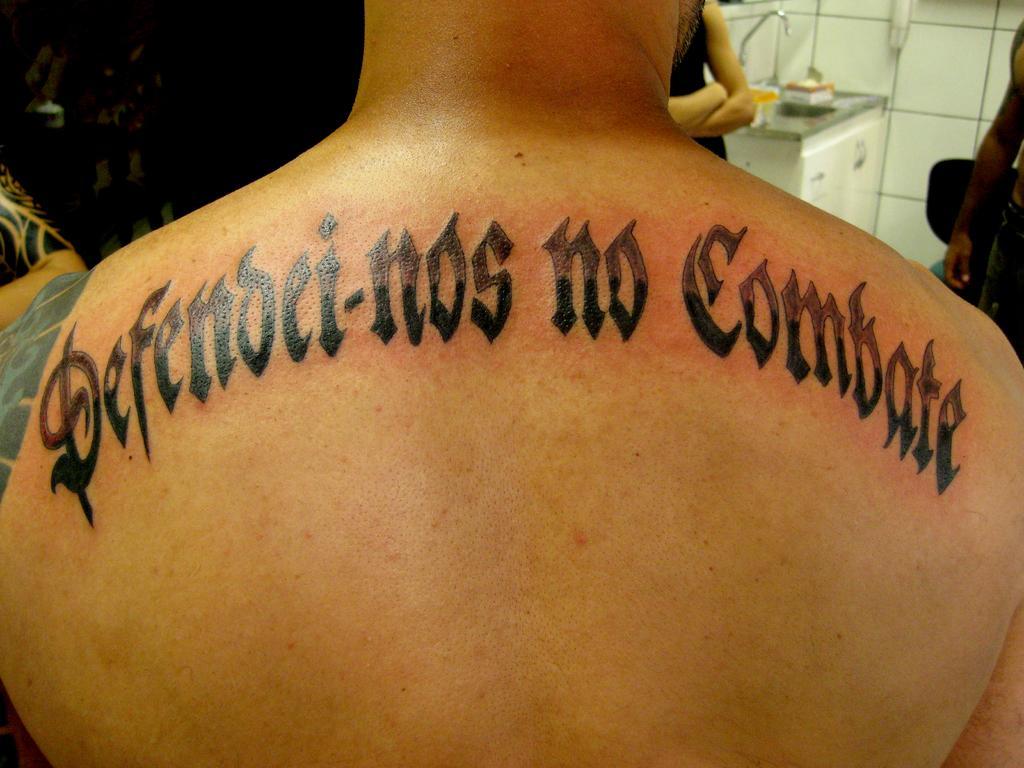Describe this image in one or two sentences. In this image there is a person wearing a tattoo. Before him there are people. There is a table having few objects. Behind there is a wall. 